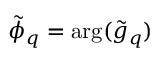Convert formula to latex. <formula><loc_0><loc_0><loc_500><loc_500>\tilde { \phi } _ { q } = \arg ( \tilde { g } _ { q } )</formula> 